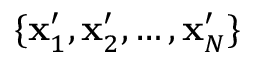<formula> <loc_0><loc_0><loc_500><loc_500>\{ x _ { 1 } ^ { \prime } , x _ { 2 } ^ { \prime } , \dots , x _ { N } ^ { \prime } \}</formula> 